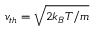Convert formula to latex. <formula><loc_0><loc_0><loc_500><loc_500>v _ { t h } = \sqrt { 2 k _ { B } T / m }</formula> 